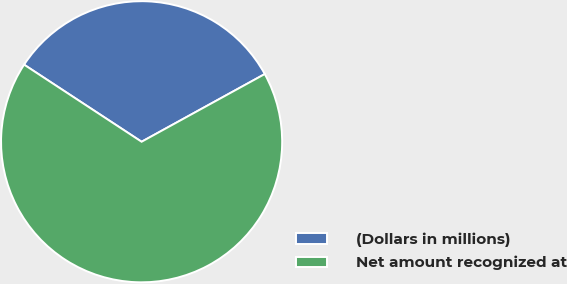<chart> <loc_0><loc_0><loc_500><loc_500><pie_chart><fcel>(Dollars in millions)<fcel>Net amount recognized at<nl><fcel>32.76%<fcel>67.24%<nl></chart> 